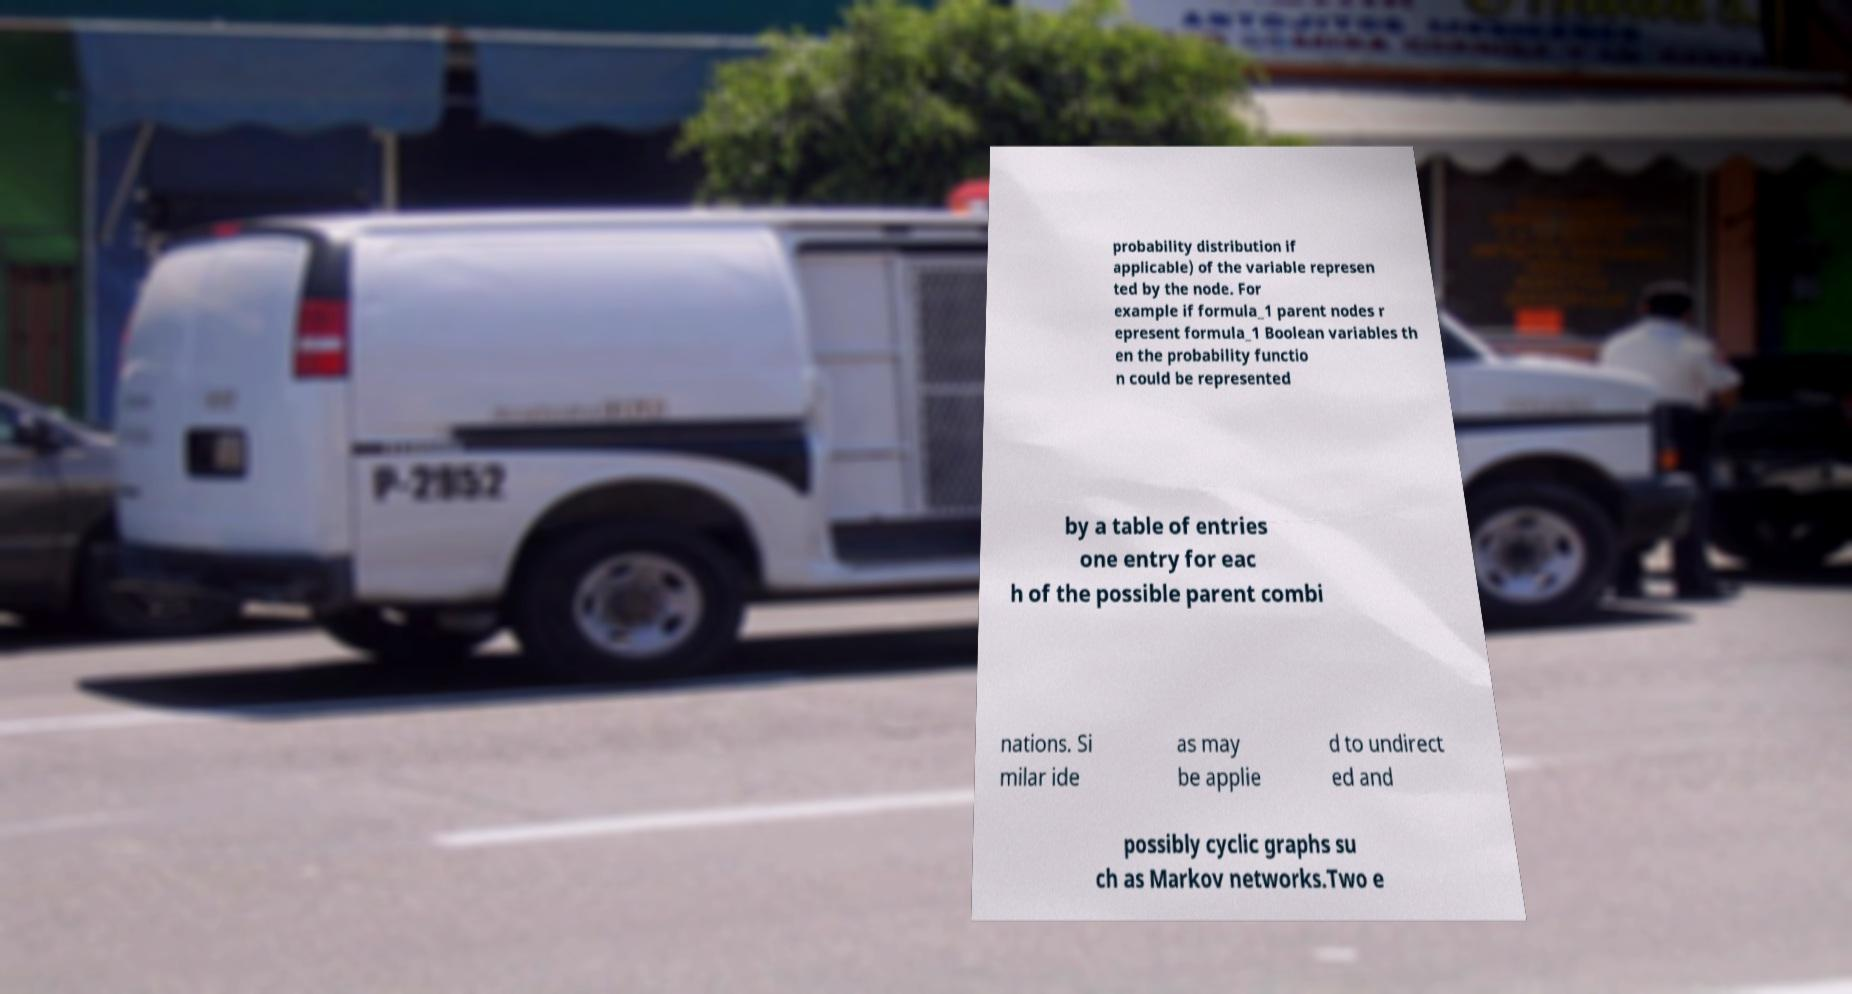Please identify and transcribe the text found in this image. probability distribution if applicable) of the variable represen ted by the node. For example if formula_1 parent nodes r epresent formula_1 Boolean variables th en the probability functio n could be represented by a table of entries one entry for eac h of the possible parent combi nations. Si milar ide as may be applie d to undirect ed and possibly cyclic graphs su ch as Markov networks.Two e 